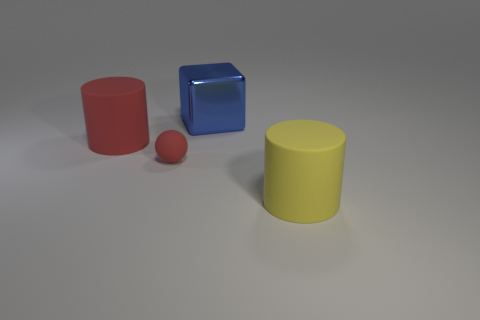Add 4 cyan matte cylinders. How many objects exist? 8 Subtract all balls. How many objects are left? 3 Add 4 red cylinders. How many red cylinders exist? 5 Subtract 0 gray blocks. How many objects are left? 4 Subtract all blue objects. Subtract all matte cylinders. How many objects are left? 1 Add 1 yellow things. How many yellow things are left? 2 